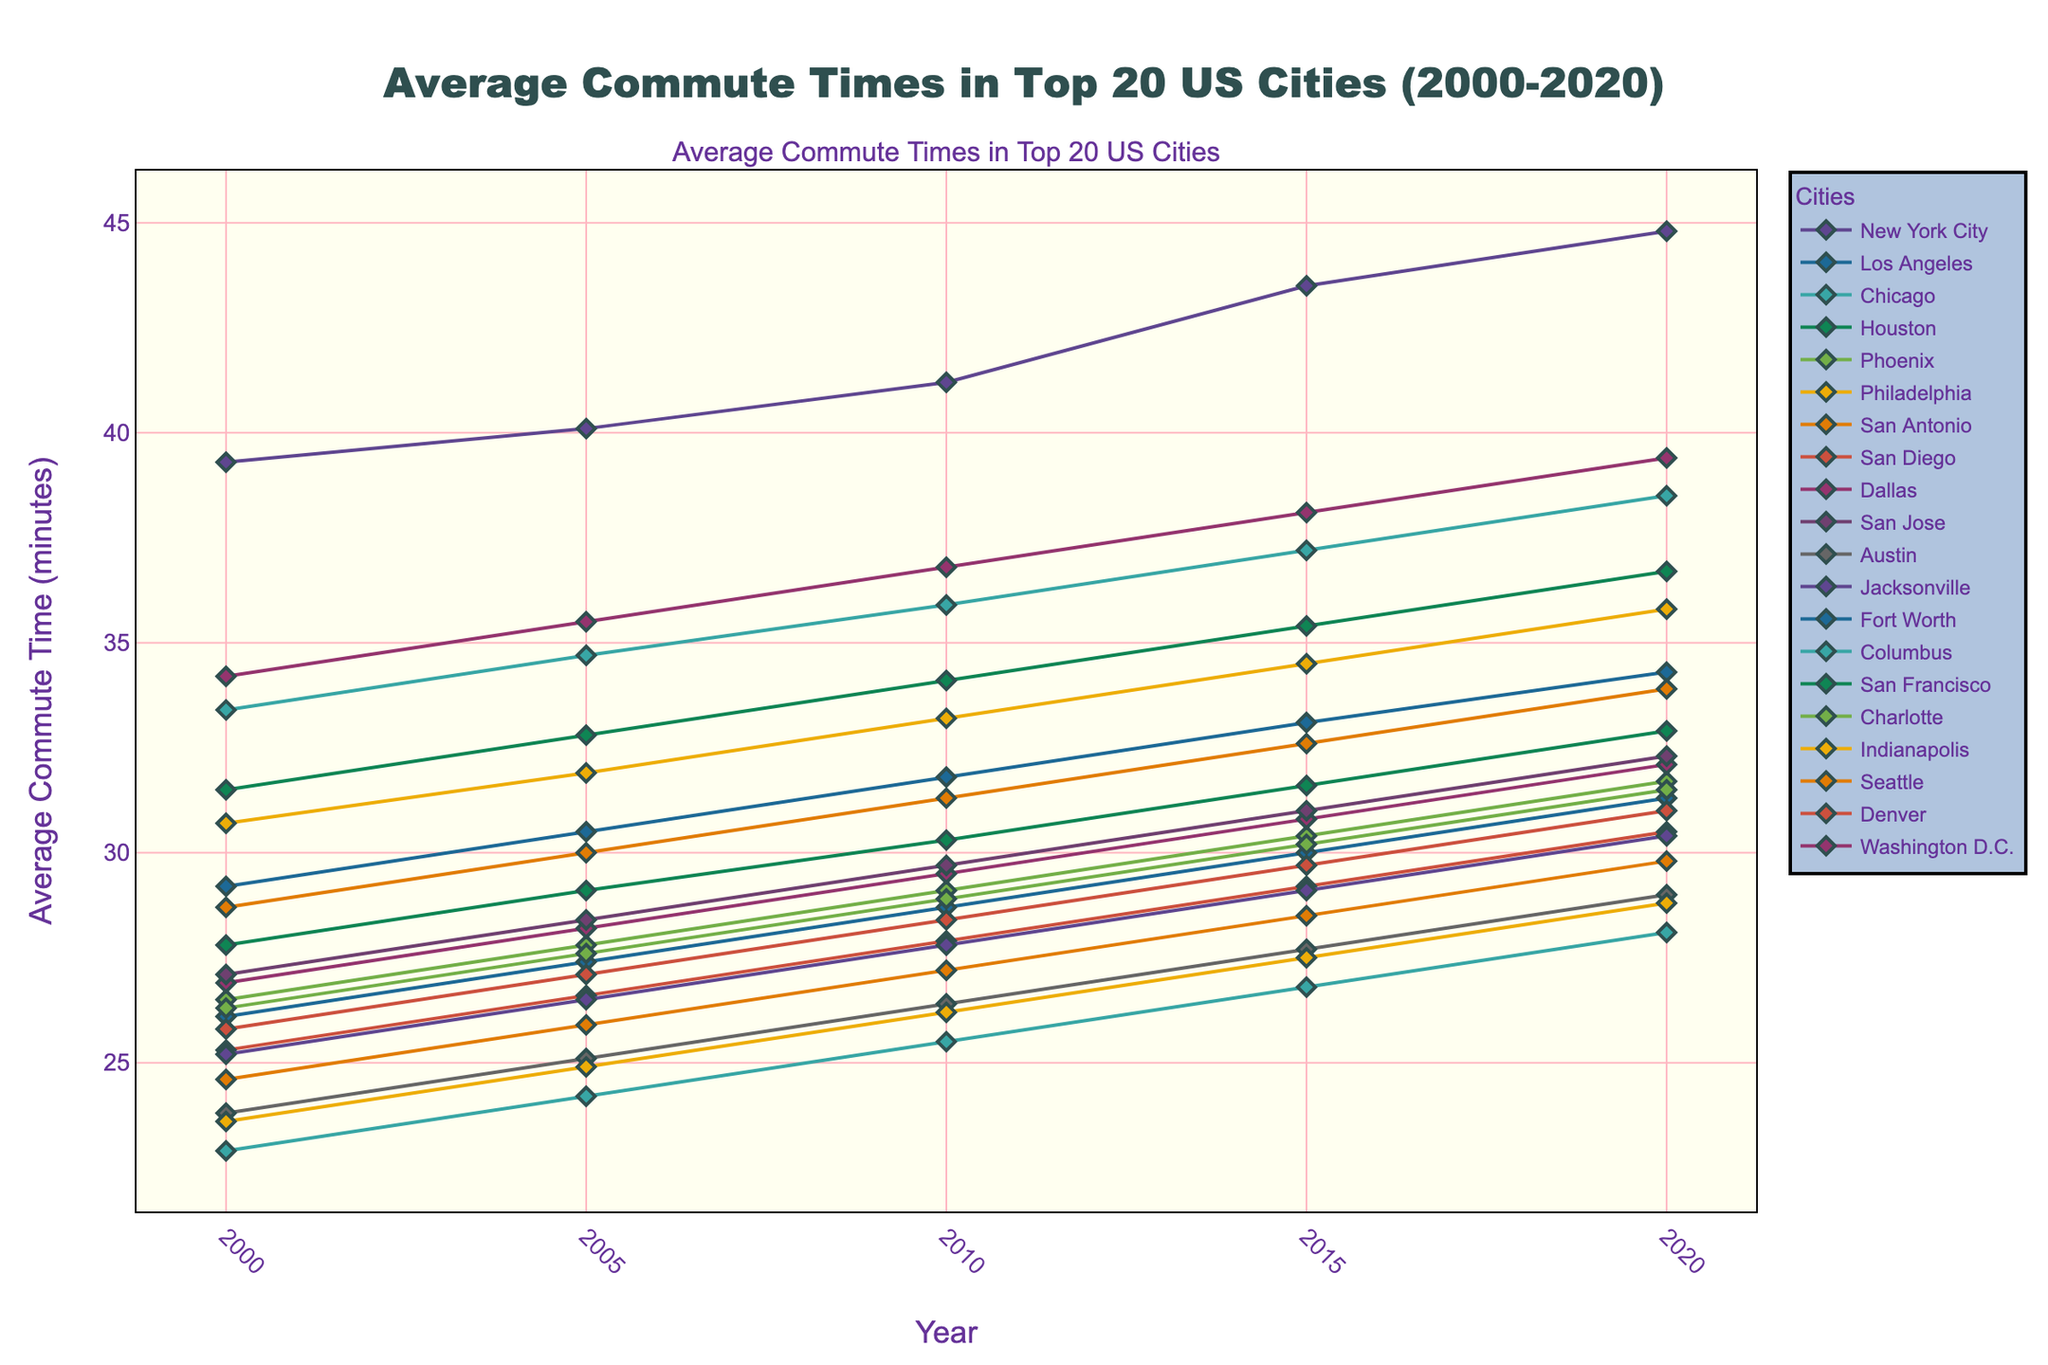Which city had the highest average commute time in 2020? Look at the value of the highest point on the chart in 2020 on the y-axis and find the corresponding city.
Answer: New York City Which city had the smallest increase in average commute time from 2000 to 2020? Calculate the difference in average commute times for each city between 2000 and 2020 and find the smallest difference.
Answer: San Antonio Which cities had an average commute time greater than 35 minutes in 2020? Look at the y-axis values for 2020 and identify cities with values greater than 35 minutes.
Answer: New York City, Chicago, Philadelphia, Washington D.C., San Francisco How much did the average commute time in Los Angeles increase from 2000 to 2020? Subtract the average commute time in Los Angeles in 2000 from its average commute time in 2020.
Answer: 34.3 - 29.2 = 5.1 minutes Which two cities had the closest average commute times in 2020? Find the two cities with the smallest difference in their average commute times in 2020.
Answer: Austin and Indianapolis Which year did Seattle's average commute time first exceed 30 minutes? Identify the point at which Seattle's commute time crosses 30 minutes and note the corresponding year.
Answer: 2005 Compare the trend of average commute times for Houston and Dallas from 2000 to 2020. Observe the slopes and relative positions of the lines representing Houston and Dallas across the years.
Answer: Both cities show an increasing trend, with Dallas consistently having slightly higher values than Houston Which city had a steeper increase in average commute time from 2000 to 2020, San Diego or Phoenix? Calculate the difference over the years for both cities and compare these values.
Answer: Phoenix had a steeper increase (5.2 minutes compared to San Diego's 5.2 minutes) What is the average increase in commute time per year for Chicago from 2000 to 2020? Divide the total increase in Chicago's average commute time by the number of years (2020-2000).
Answer: (38.5 - 33.4) / 20 = 0.255 minutes per year 